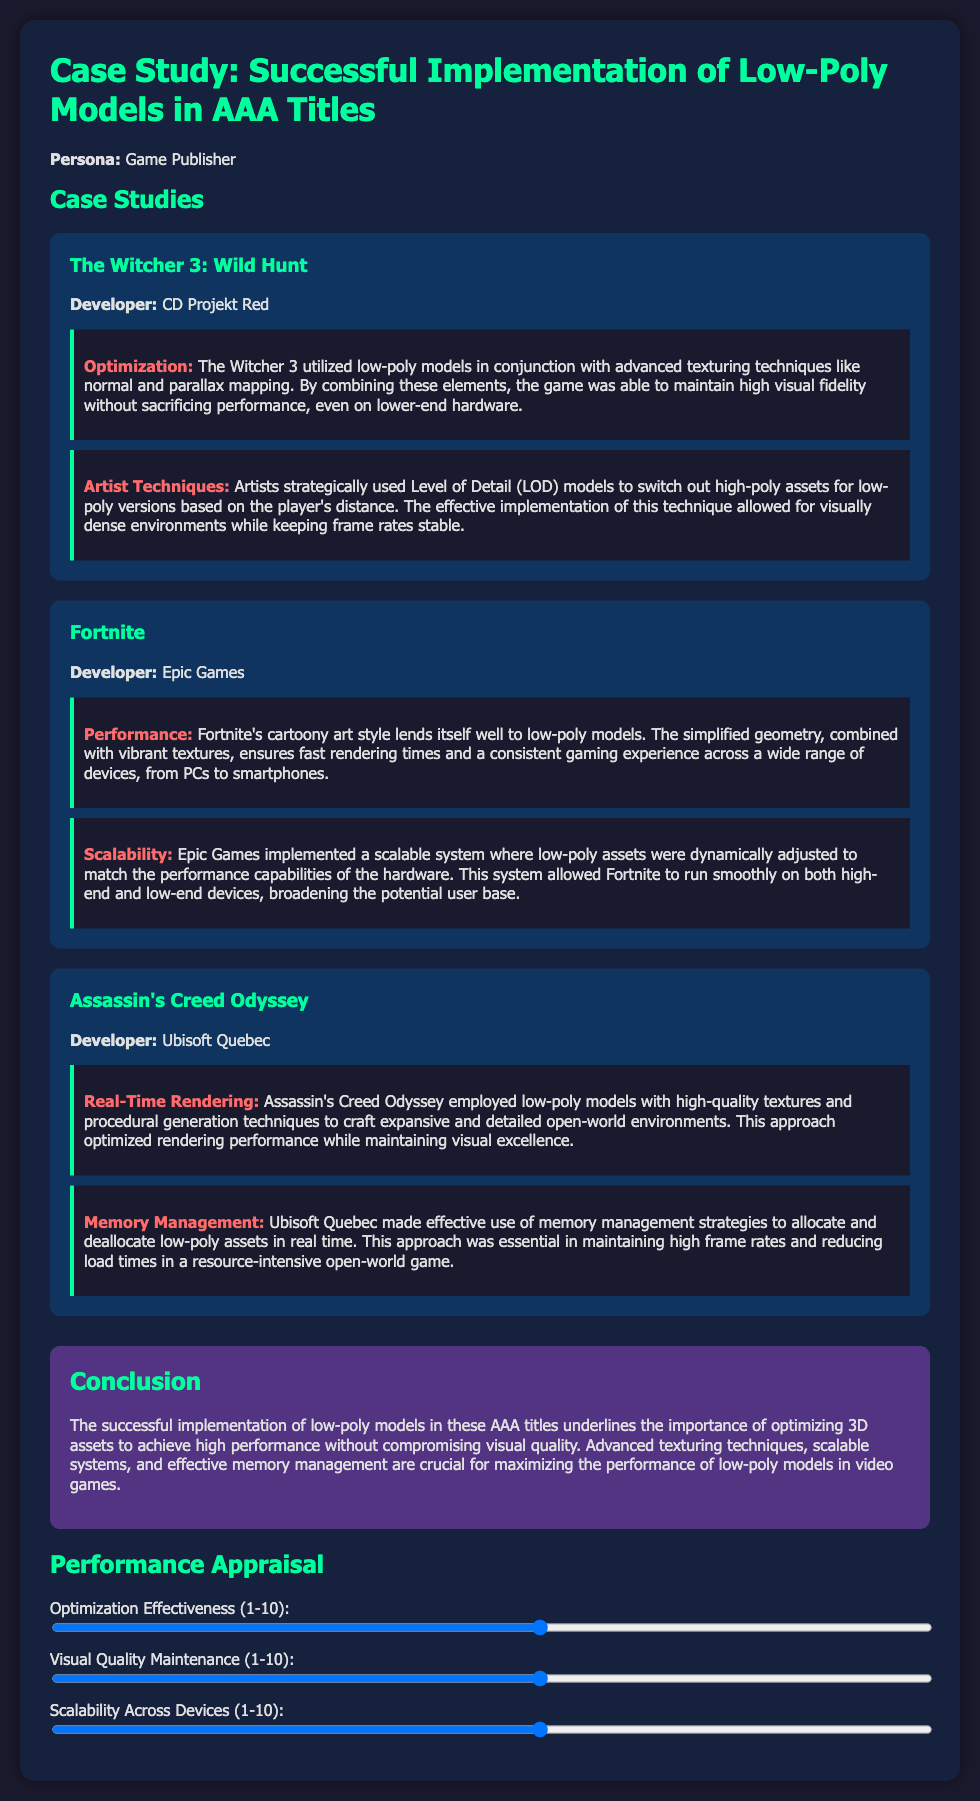What game did CD Projekt Red develop? The document mentions "The Witcher 3: Wild Hunt" as developed by CD Projekt Red.
Answer: The Witcher 3: Wild Hunt What is one technique used in The Witcher 3 for performance optimization? The document states that The Witcher 3 utilized low-poly models in conjunction with advanced texturing techniques like normal and parallax mapping.
Answer: Normal and parallax mapping How did Fortnite ensure consistent gaming experience across devices? The document explains that Fortnite's cartoony art style and simplified geometry ensured fast rendering times and a consistent gaming experience across various devices.
Answer: Simplified geometry What aspect of memory management was emphasized in Assassin's Creed Odyssey? The document highlights that effective memory management strategies were crucial for maintaining high frame rates and reducing load times.
Answer: High frame rates and reducing load times What rating scale is used for the performance appraisal? The document specifies that a rating scale from 1 to 10 is used for evaluating optimization effectiveness, visual quality, and scalability across devices.
Answer: 1 to 10 What is the focus of the conclusion in the case study? The conclusion emphasizes the importance of optimizing 3D assets for high performance without compromising visual quality.
Answer: Optimizing 3D assets for high performance What visual technique contributed to the real-time rendering in Assassin's Creed Odyssey? The document mentions the use of low-poly models combined with high-quality textures and procedural generation techniques as a strategy.
Answer: Procedural generation techniques How did Epic Games adjust low-poly assets in Fortnite? The document describes that Epic Games implemented a scalable system where low-poly assets were dynamically adjusted based on hardware performance capabilities.
Answer: Scalable system 